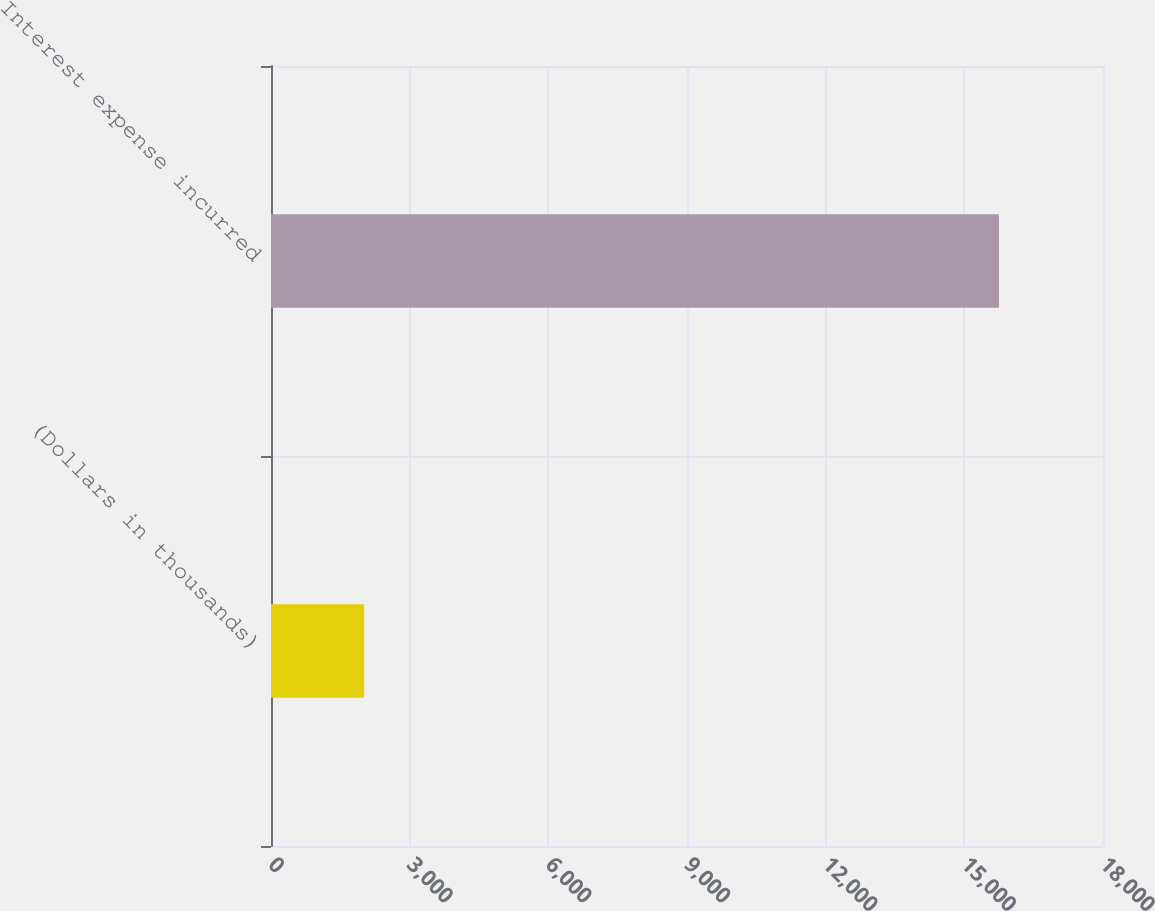Convert chart to OTSL. <chart><loc_0><loc_0><loc_500><loc_500><bar_chart><fcel>(Dollars in thousands)<fcel>Interest expense incurred<nl><fcel>2015<fcel>15749<nl></chart> 